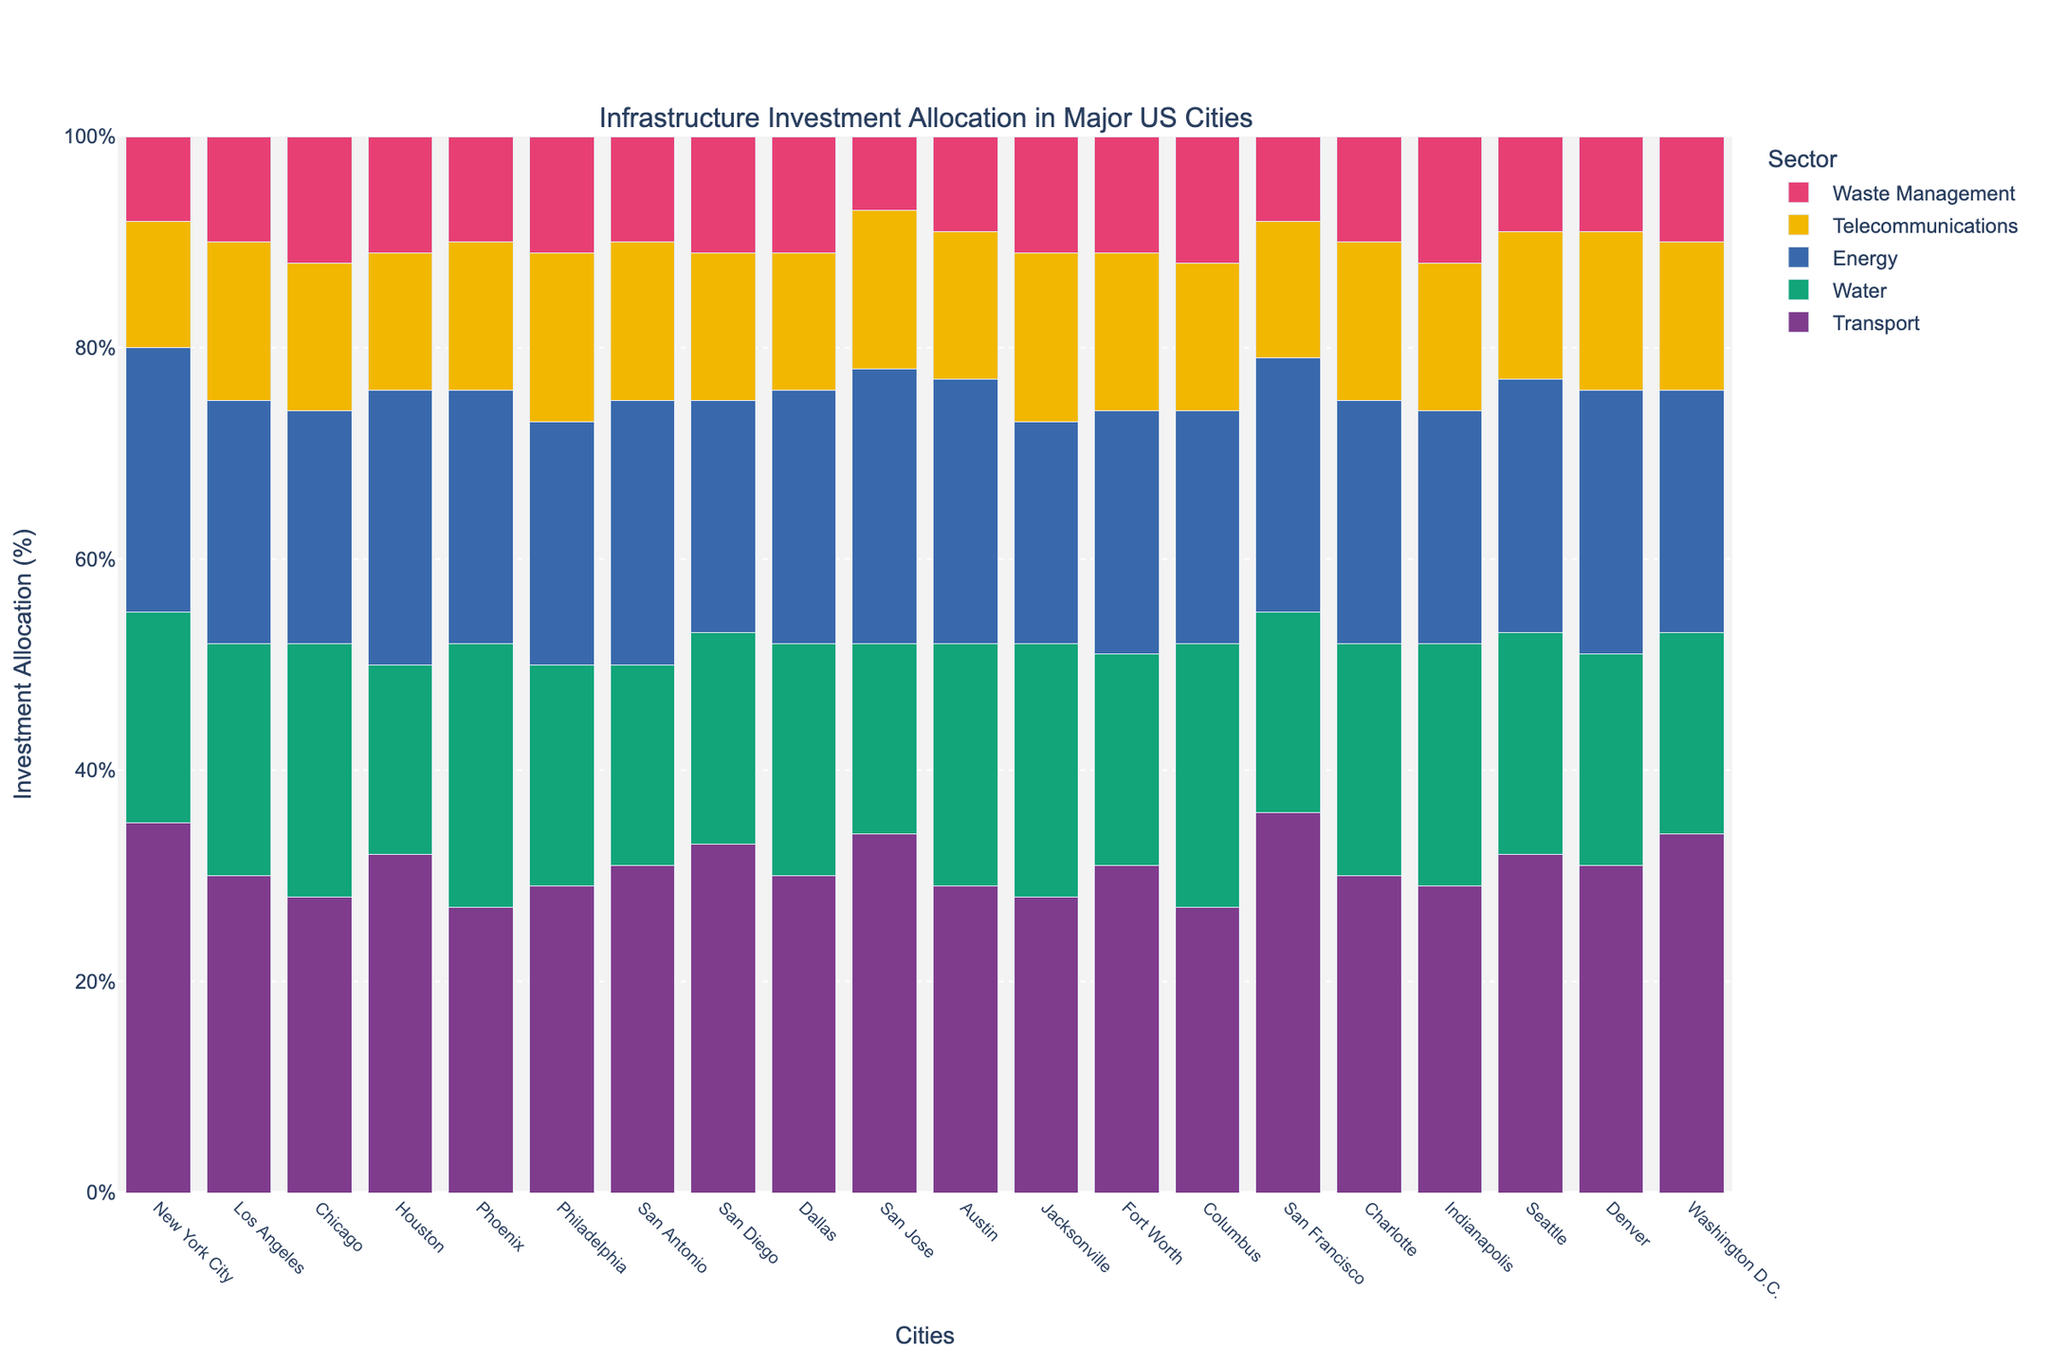Which city has the highest allocation for transport? Scan the figure for the tallest bar in the transport sector (usually the first color in the stack).
Answer: San Francisco Which sector has the least investment in New York City? Look for the shortest segment in the stack of bars for New York City, which will represent the sector with the least investment.
Answer: Waste Management How does energy investment in Houston compare to that in San Jose? Compare the heights of the bars representing energy for Houston and San Jose.
Answer: Both are equal at 26% What is the total percentage allocation for Philadelphia across all sectors? Sum the heights of all segments in the bar for Philadelphia (29 + 21 + 23 + 16 + 11).
Answer: 100% Which city has the highest combined allocation for telecommunications and waste management? Look for the city with the highest cumulative height for the telecommunications and waste management segments (last two colors in each stack). Calculate the sum for each city.
Answer: Philadelphia and Jacksonville In which city is the investment in water higher than that in transport? Look for bars where the water segment is taller than the transport segment.
Answer: None What is the difference in waste management allocation between Chicago and Dallas? Subtract the height of Dallas's waste management segment from that of Chicago's (12 - 11).
Answer: 1% Which city has the equal allocation for both water and energy sectors? Find the bar(s) where the water and energy segments are of equal height.
Answer: San Jose Is the water investment in San Antonio higher or lower than in Los Angeles? Compare the heights of the water segments for San Antonio and Los Angeles.
Answer: Lower Which three cities have the highest transport investment allocations? Identify the tallest three bars in the transport sector.
Answer: San Francisco, New York City, San Jose 